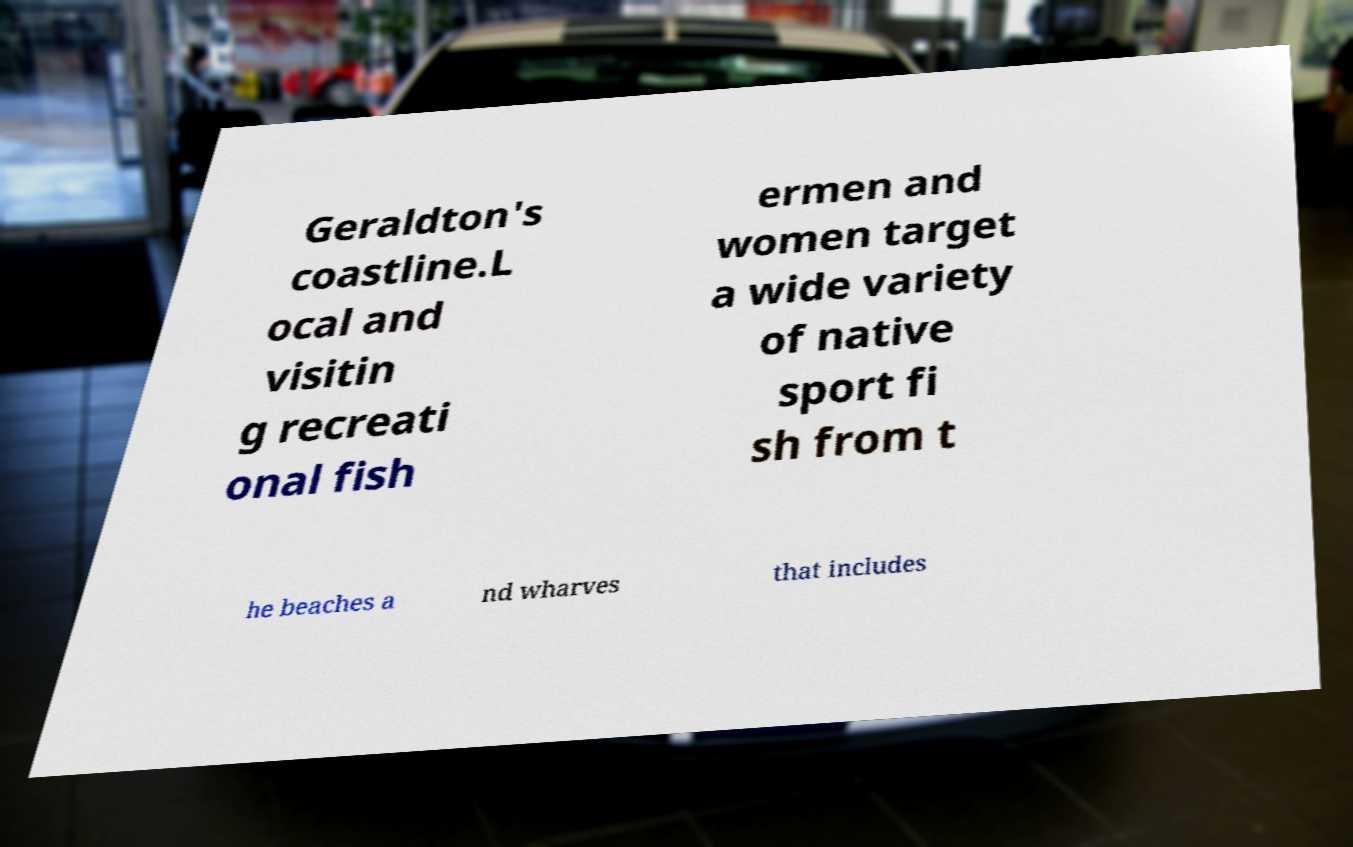There's text embedded in this image that I need extracted. Can you transcribe it verbatim? Geraldton's coastline.L ocal and visitin g recreati onal fish ermen and women target a wide variety of native sport fi sh from t he beaches a nd wharves that includes 